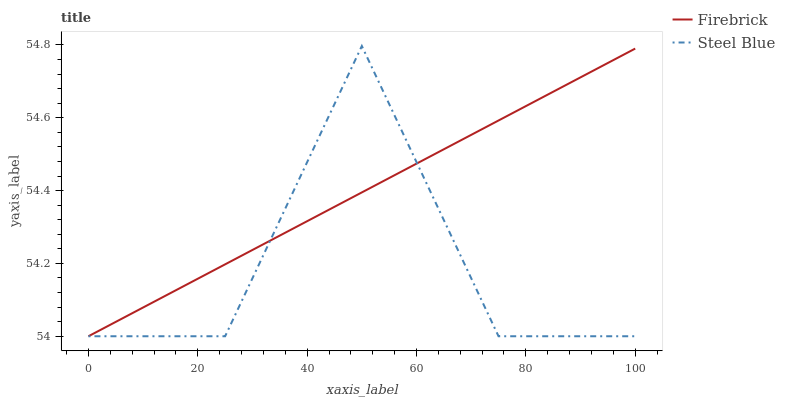Does Steel Blue have the minimum area under the curve?
Answer yes or no. Yes. Does Firebrick have the maximum area under the curve?
Answer yes or no. Yes. Does Steel Blue have the maximum area under the curve?
Answer yes or no. No. Is Firebrick the smoothest?
Answer yes or no. Yes. Is Steel Blue the roughest?
Answer yes or no. Yes. Is Steel Blue the smoothest?
Answer yes or no. No. Does Firebrick have the lowest value?
Answer yes or no. Yes. Does Steel Blue have the highest value?
Answer yes or no. Yes. Does Steel Blue intersect Firebrick?
Answer yes or no. Yes. Is Steel Blue less than Firebrick?
Answer yes or no. No. Is Steel Blue greater than Firebrick?
Answer yes or no. No. 